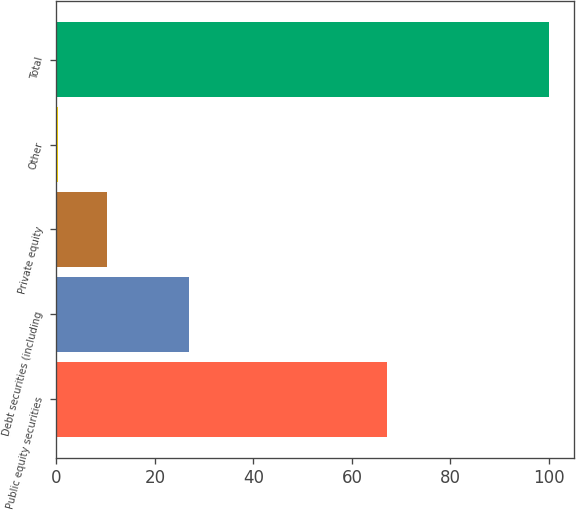Convert chart to OTSL. <chart><loc_0><loc_0><loc_500><loc_500><bar_chart><fcel>Public equity securities<fcel>Debt securities (including<fcel>Private equity<fcel>Other<fcel>Total<nl><fcel>67.2<fcel>26.9<fcel>10.27<fcel>0.3<fcel>100<nl></chart> 